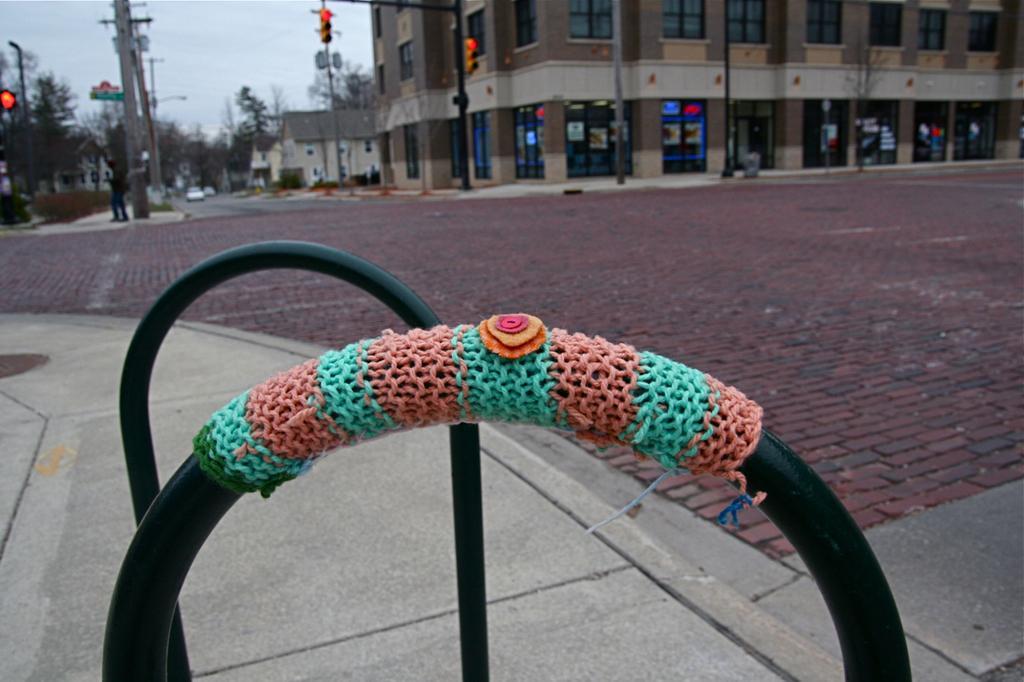Can you describe this image briefly? In this image we can see few buildings. There are few vehicles on the road. There are many trees and plants in the image. We can see some reflection on the glasses of the building at the right side of the image. There are few poles in the image. We can see a person at the left side of the image. We can see the sky in the image. There are few traffic lights in the image. 